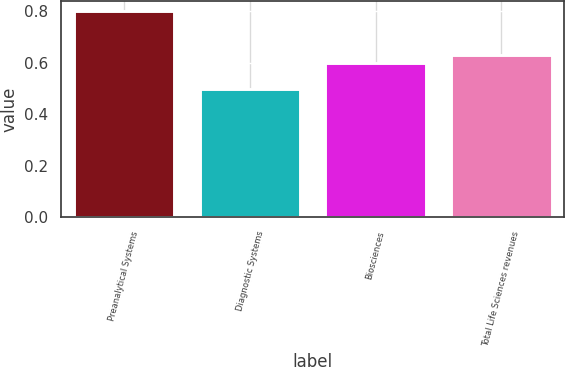Convert chart to OTSL. <chart><loc_0><loc_0><loc_500><loc_500><bar_chart><fcel>Preanalytical Systems<fcel>Diagnostic Systems<fcel>Biosciences<fcel>Total Life Sciences revenues<nl><fcel>0.8<fcel>0.5<fcel>0.6<fcel>0.63<nl></chart> 